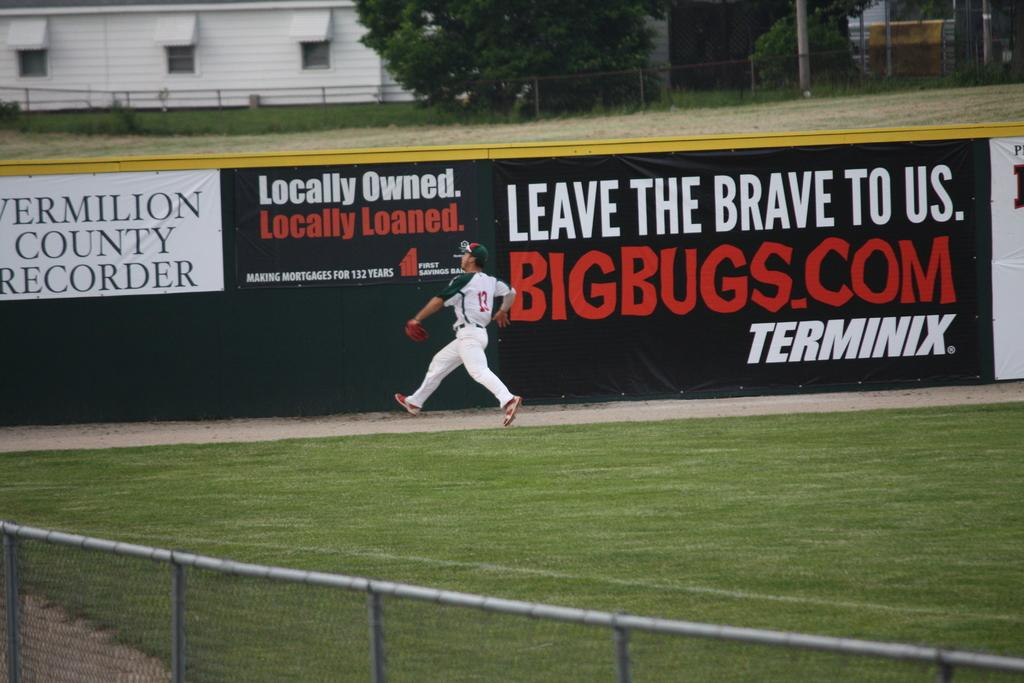<image>
Offer a succinct explanation of the picture presented. A #13 baseball player is on a field with an advertisement in the back stating LEAVE THE BRAVE TO US BIGBUGS.COM TERMINEX 